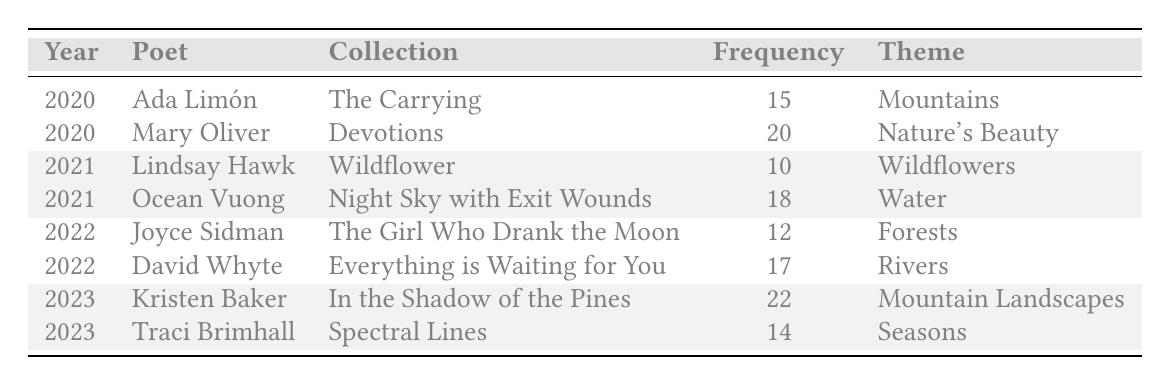What is the frequency of "Water" as a theme in 2021? In the table, for the year 2021, the poet Ocean Vuong has a frequency of 18 associated with the theme "Water."
Answer: 18 Which poet published a collection in 2020 that focuses on “Mountains”? The table shows that Ada Limón published "The Carrying" in 2020 with a theme frequency of 15 for "Mountains."
Answer: Ada Limón What is the average frequency of nature themes across all years? Adding up the frequencies: 15 (Ada Limón) + 20 (Mary Oliver) + 10 (Lindsay Hawk) + 18 (Ocean Vuong) + 12 (Joyce Sidman) + 17 (David Whyte) + 22 (Kristen Baker) + 14 (Traci Brimhall) = 118. There are 8 entries, so the average is 118 / 8 = 14.75.
Answer: 14.75 Is "Nature's Beauty" the most frequently referenced theme in the table? The highest frequency in the table is 22, which corresponds to "Mountain Landscapes" by Kristen Baker in 2023, which means "Nature's Beauty" with a frequency of 20 is not the most frequent.
Answer: No How many more poems focus on the theme of "Mountains" compared to "Wildflowers"? The frequency for "Mountains" is 15 and for "Wildflowers" it is 10. The difference is 15 - 10 = 5.
Answer: 5 Which year had the highest total frequency of nature themes? Calculate the total frequency for each year: 2020: 15 + 20 = 35; 2021: 10 + 18 = 28; 2022: 12 + 17 = 29; 2023: 22 + 14 = 36. The highest is 2023 with 36.
Answer: 2023 How many themes focused on water-related imagery in the table? In the table, only the 2021 entry by Ocean Vuong is related to water, specifically under the theme "Water."
Answer: 1 Did any poet publish collections that explored nature themes in each of the three years? Upon review, the table shows that each poet is unique to their year. No poet appears in all three years.
Answer: No 